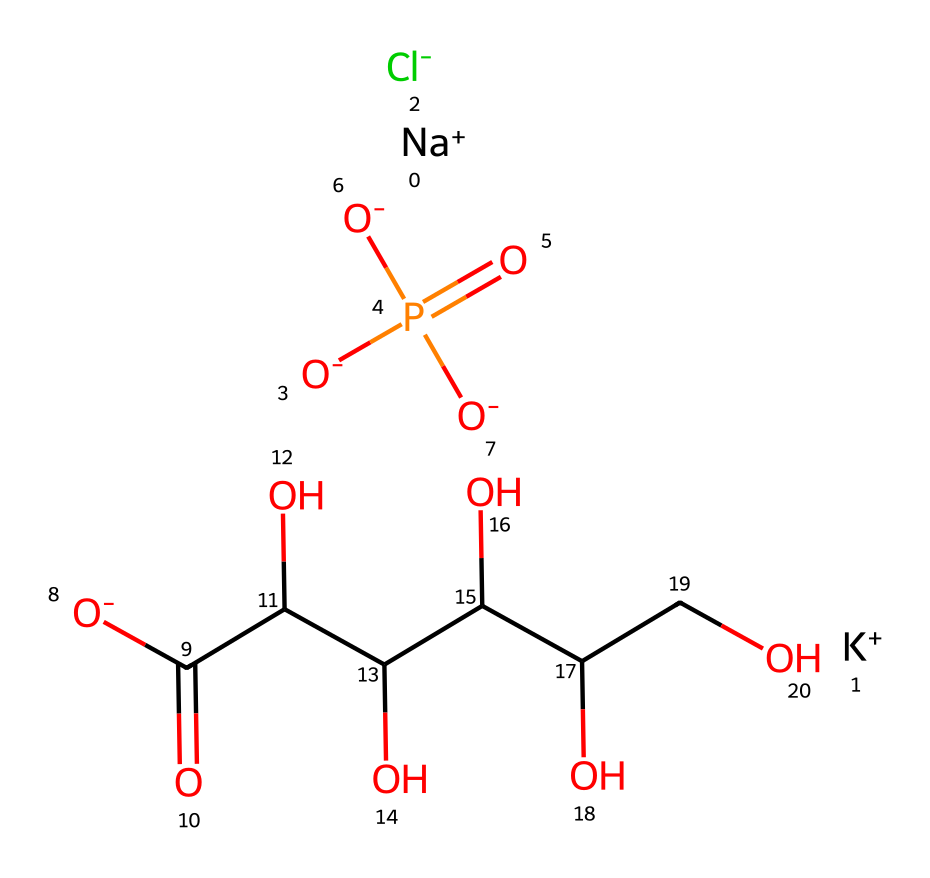what are the two cations present in this chemical? The SMILES representation shows [Na+] and [K+] as the cations. These are positively charged ions indicated by the plus sign next to their respective symbols.
Answer: sodium and potassium how many oxygen atoms are in the chemical? By analyzing the SMILES structure, there are five instances of the oxygen 'O' indicated, alongside two negative charges which could correlate with the oxygen atoms.
Answer: five what type of compound does this chemical represent? The presence of sodium, potassium, chloride, and phosphate suggests that this chemical is a type of electrolyte, typically found in rehydration solutions like sports drinks.
Answer: electrolyte which functional group is present that contains phosphorus? The chemical features a phosphate group (indicated by the presence of P and multiple oxygen atoms bonded to it), which is characteristic of phosphorus-containing compounds.
Answer: phosphate how many carbon atoms are there in this chemical? Counting the 'C' symbols in the SMILES representation shows there are six distinct carbon atoms present in the structure.
Answer: six what role do the chloride ions play in this chemical? Chloride ions act as electrolytes and are essential for maintaining fluid balance and nerve function, highlighting their critical role in hydration and muscle function in sports drinks.
Answer: fluid balance which part of the chemical is responsible for the sour taste? The carboxylic acid group can be responsible for a sour taste, represented here by the presence of carbon and oxygen in the -COOH structure, typically associated with sour flavors.
Answer: carboxylic acid group 